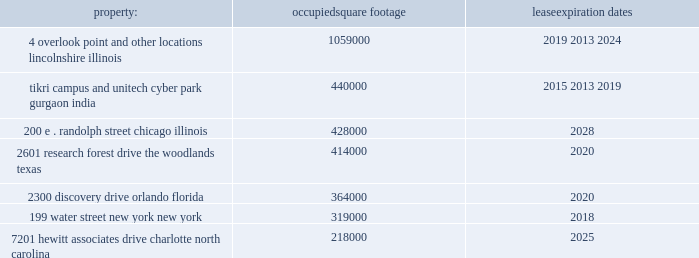Approximately 99% ( 99 % ) of the outstanding shares of common stock of aon corporation were held within the dtc system .
The class a ordinary shares of aon plc are , at present , eligible for deposit and clearing within the dtc system .
In connection with the closing of the redomestication , we entered into arrangements with dtc whereby we agreed to indemnify dtc for any stamp duty and/or sdrt that may be assessed upon it as a result of its service as a depository and clearing agency for our class a ordinary shares .
In addition , we have obtained a ruling from hmrc in respect of the stamp duty and sdrt consequences of the reorganization , and sdrt has been paid in accordance with the terms of this ruling in respect of the deposit of class a ordinary shares with the initial depository .
Dtc will generally have discretion to cease to act as a depository and clearing agency for the class a ordinary shares .
If dtc determines at any time that the class a ordinary shares are not eligible for continued deposit and clearance within its facilities , then we believe the class a ordinary shares would not be eligible for continued listing on a u.s .
Securities exchange or inclusion in the s&p 500 and trading in the class a ordinary shares would be disrupted .
While we would pursue alternative arrangements to preserve our listing and maintain trading , any such disruption could have a material adverse effect on the trading price of the class a ordinary shares .
Item 1b .
Unresolved staff comments .
Item 2 .
Properties .
We have offices in various locations throughout the world .
Substantially all of our offices are located in leased premises .
We maintain our corporate headquarters at 122 leadenhall street , london , england , where we occupy approximately 190000 square feet of space under an operating lease agreement that expires in 2034 .
We own one significant building at pallbergweg 2-4 , amsterdam , the netherlands ( 150000 square feet ) .
The following are additional significant leased properties , along with the occupied square footage and expiration .
Property : occupied square footage expiration .
The locations in lincolnshire , illinois , gurgaon , india , the woodlands , texas , orlando , florida , and charlotte , north carolina , are primarily dedicated to our hr solutions segment .
The other locations listed above house personnel from both of our reportable segments .
In general , no difficulty is anticipated in negotiating renewals as leases expire or in finding other satisfactory space if the premises become unavailable .
We believe that the facilities we currently occupy are adequate for the purposes for which they are being used and are well maintained .
In certain circumstances , we may have unused space and may seek to sublet such space to third parties , depending upon the demands for office space in the locations involved .
See note 7 "lease commitments" of the notes to consolidated financial statements in part ii , item 8 of this report for information with respect to our lease commitments as of december 31 , 2015 .
Item 3 .
Legal proceedings .
We hereby incorporate by reference note 14 "commitments and contingencies" of the notes to consolidated financial statements in part ii , item 8 of this report .
Item 4 .
Mine safety disclosure .
Not applicable. .
How many years are left till the lease expiration date for the building of aon's corporate headquarters? 
Computations: (2034 - 2015)
Answer: 19.0. 